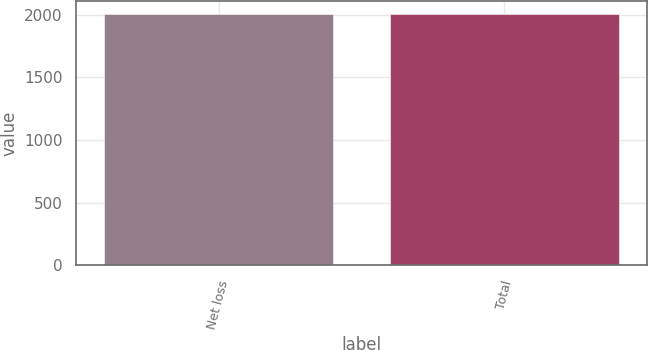Convert chart to OTSL. <chart><loc_0><loc_0><loc_500><loc_500><bar_chart><fcel>Net loss<fcel>Total<nl><fcel>2008<fcel>2008.1<nl></chart> 